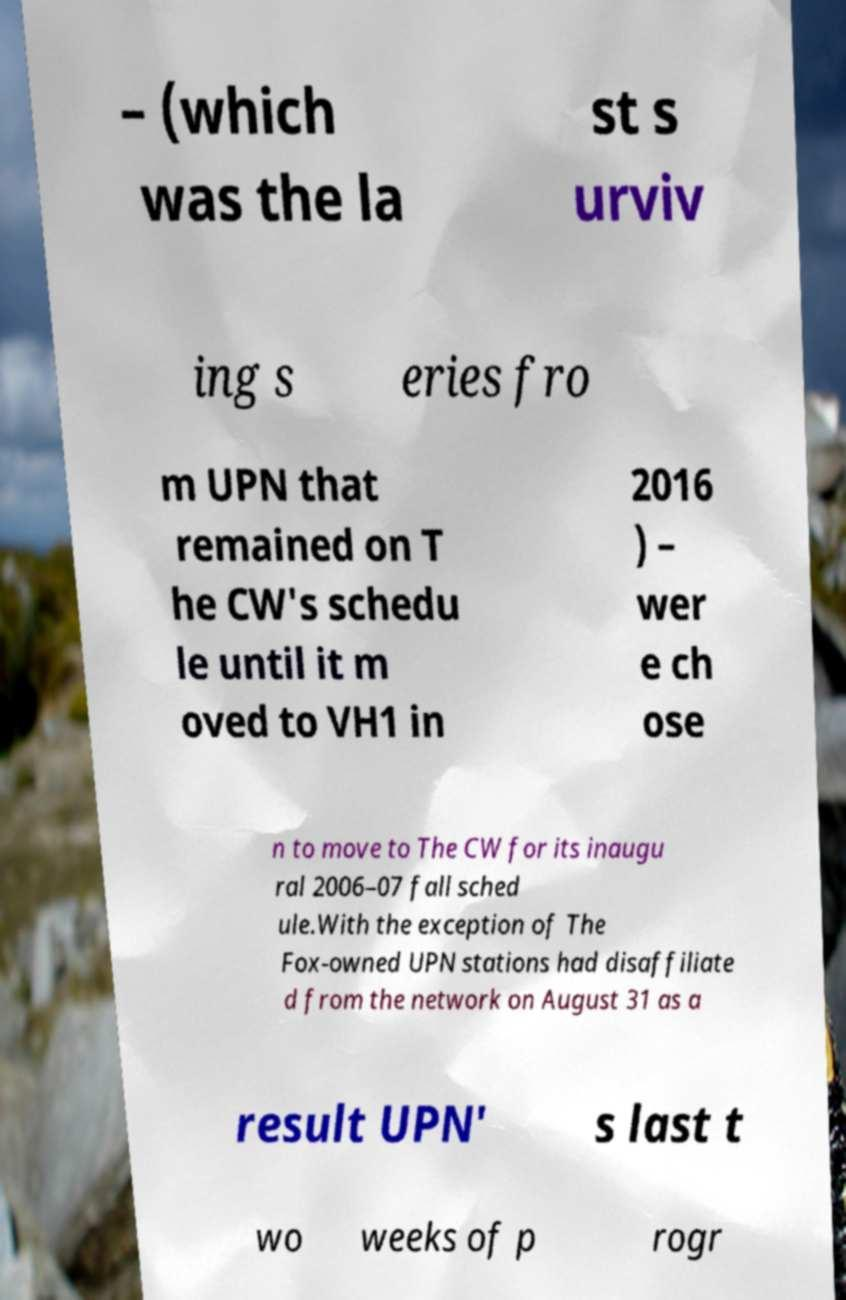Could you assist in decoding the text presented in this image and type it out clearly? – (which was the la st s urviv ing s eries fro m UPN that remained on T he CW's schedu le until it m oved to VH1 in 2016 ) – wer e ch ose n to move to The CW for its inaugu ral 2006–07 fall sched ule.With the exception of The Fox-owned UPN stations had disaffiliate d from the network on August 31 as a result UPN' s last t wo weeks of p rogr 